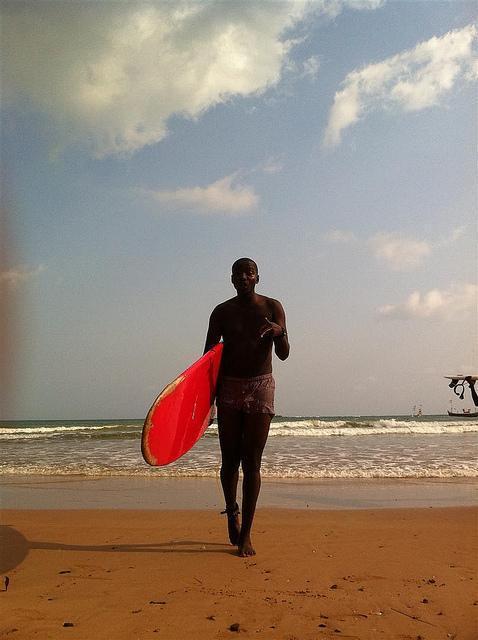How many boards in the photo?
Give a very brief answer. 1. How many kites do you  see?
Give a very brief answer. 0. 